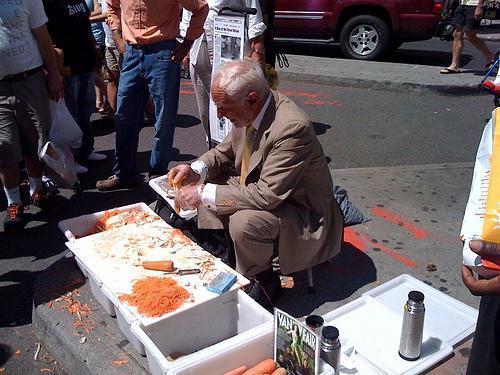What is the orange item?
Pick the correct solution from the four options below to address the question.
Options: Carrot, pumpkin pie, traffic cone, sticky note. Carrot. 